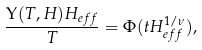<formula> <loc_0><loc_0><loc_500><loc_500>\frac { \Upsilon ( T , H ) H _ { e f f } } { T } = \Phi ( t H _ { e f f } ^ { 1 / \nu } ) ,</formula> 